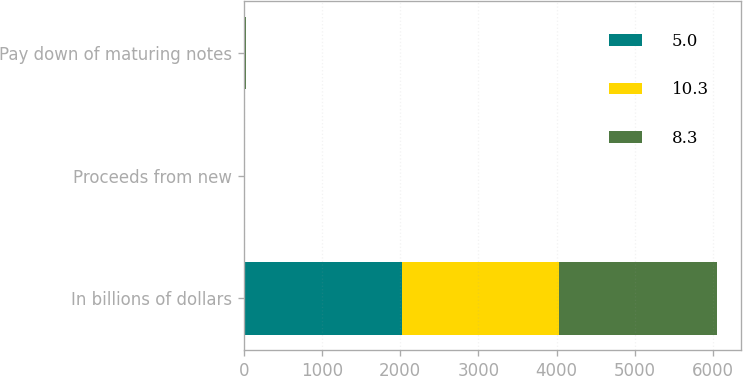Convert chart to OTSL. <chart><loc_0><loc_0><loc_500><loc_500><stacked_bar_chart><ecel><fcel>In billions of dollars<fcel>Proceeds from new<fcel>Pay down of maturing notes<nl><fcel>5<fcel>2018<fcel>6.8<fcel>8.3<nl><fcel>10.3<fcel>2017<fcel>11.1<fcel>5<nl><fcel>8.3<fcel>2016<fcel>3.3<fcel>10.3<nl></chart> 